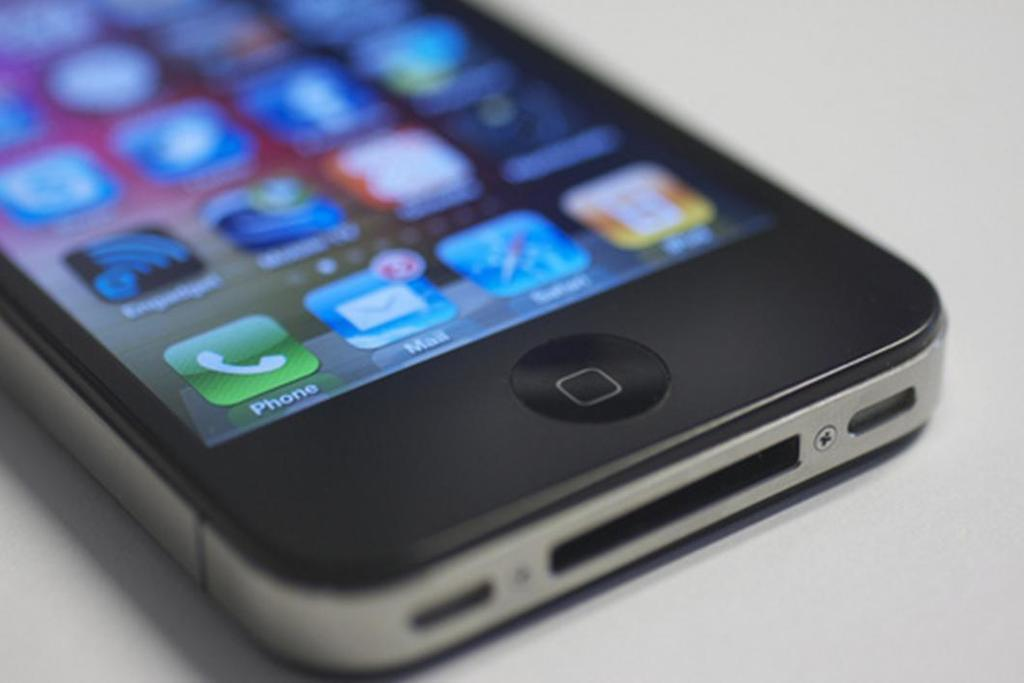Provide a one-sentence caption for the provided image. A black smartphone lying on a counter with the display screen showing and the phone and mail icon displayed. 